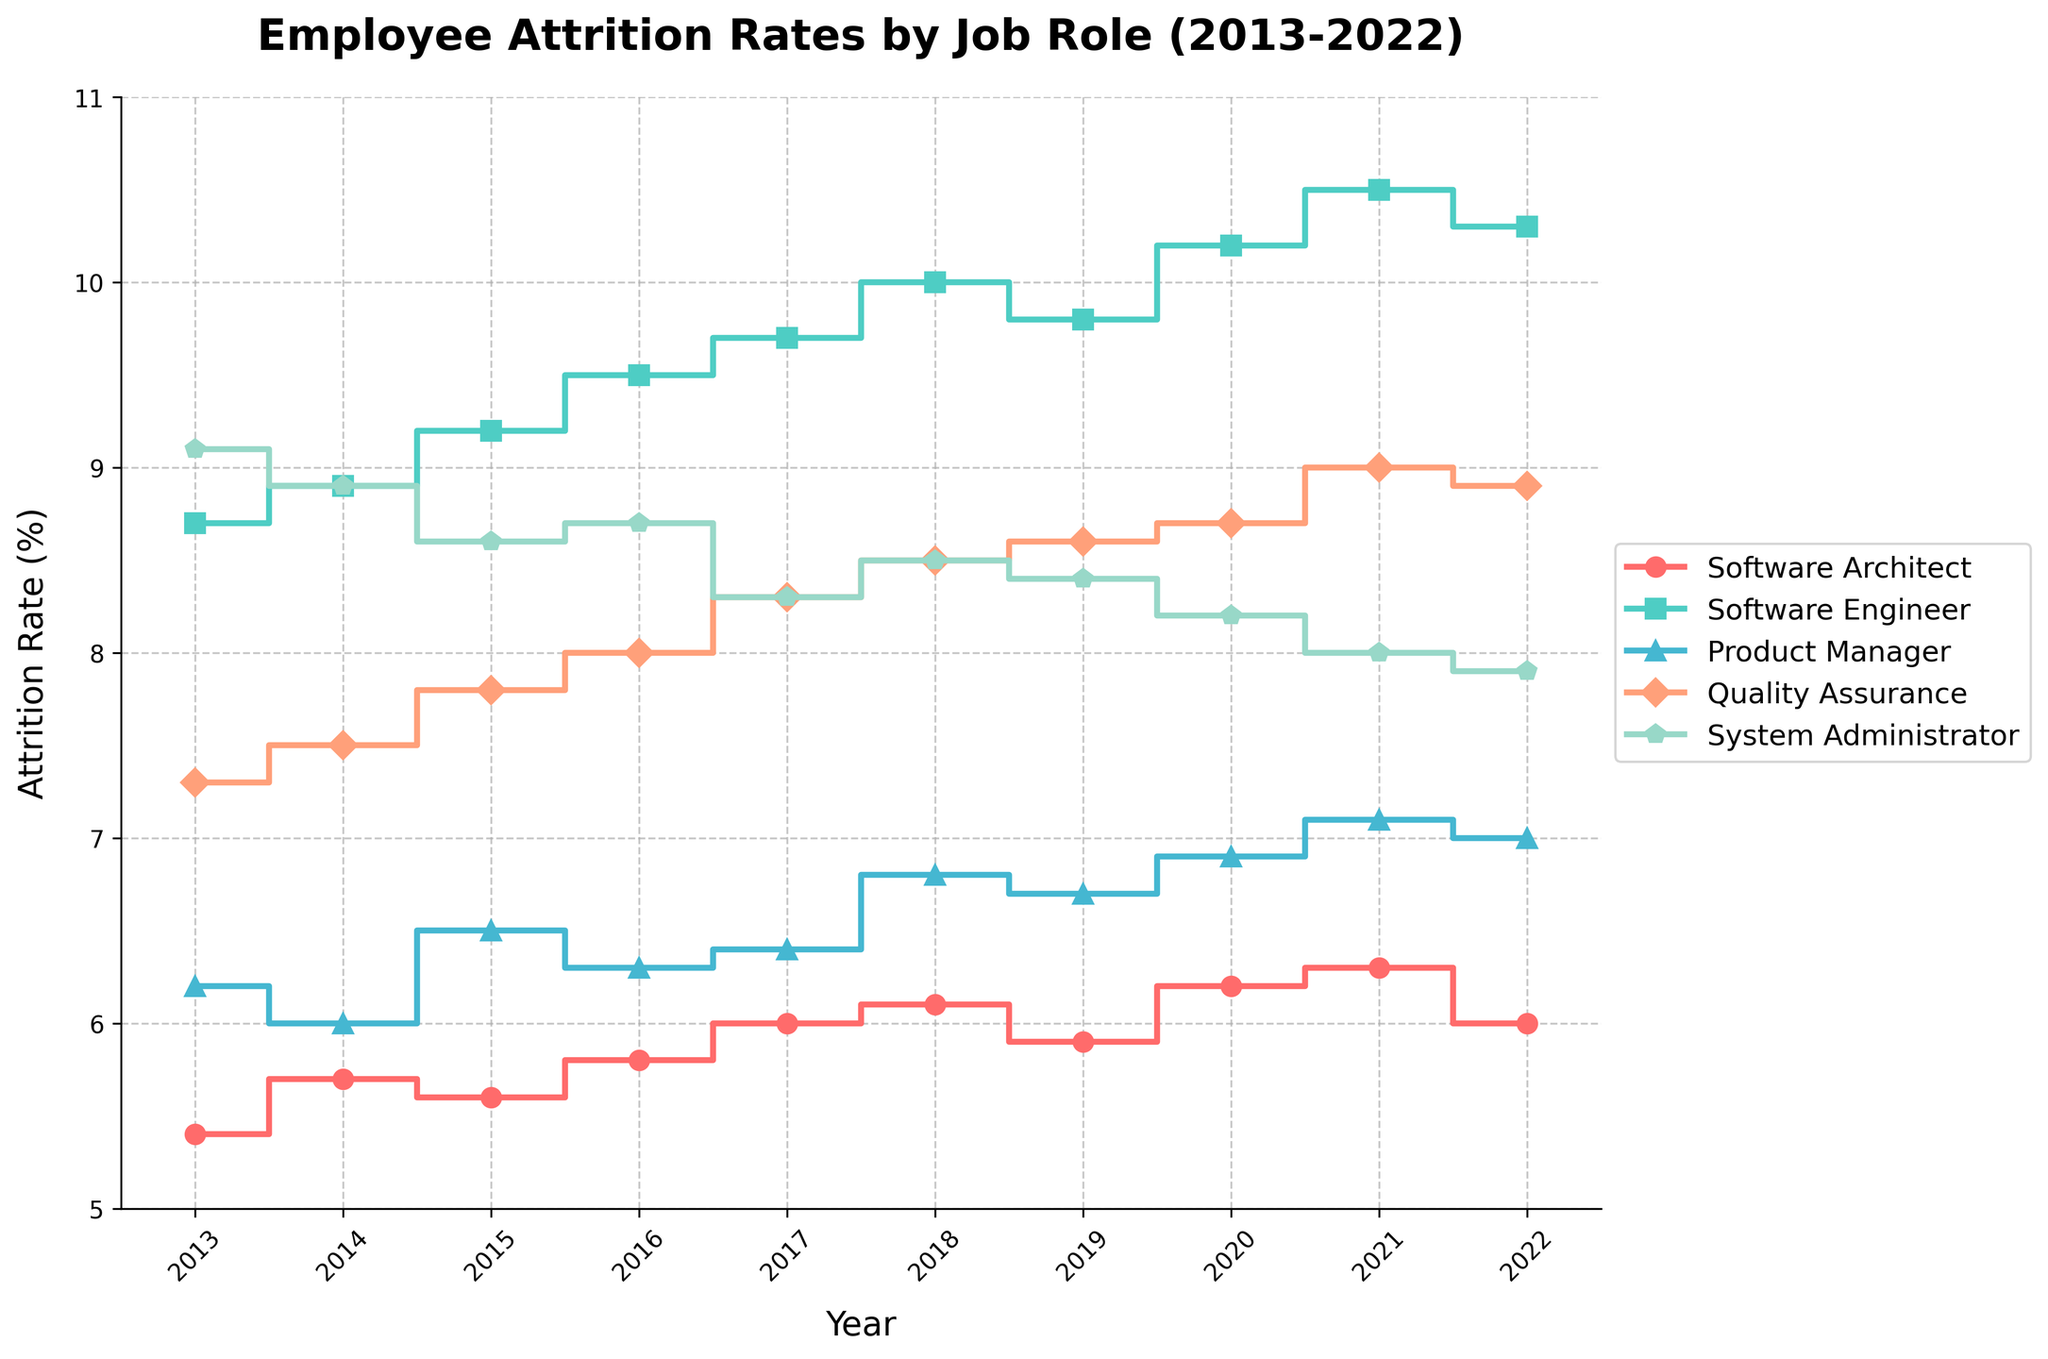Which job role had the lowest attrition rate in 2013? The data shows different job roles' attrition rates in 2013. By comparing these rates, we see that the Software Architect had the lowest attrition rate of 5.4%.
Answer: Software Architect What is the average attrition rate of Software Engineers from 2013 to 2022? To find the average, sum all the attrition rates for Software Engineers from 2013 to 2022 and divide by the number of years. The sum is 85.8 and dividing by 10 years gives us an average rate of 8.58%.
Answer: 8.58% Which job role shows the most significant increase in attrition rate from 2013 to 2022? By comparing the attrition rates from 2013 to 2022 for all job roles, Software Engineers had an increase from 8.7% to 10.3%, which is the largest increase of 1.6%.
Answer: Software Engineer What was the attrition rate for Quality Assurance in 2020? From the given plot, the attrition rate for Quality Assurance in 2020 is 8.7%.
Answer: 8.7% How did the attrition rate for Product Managers change from 2019 to 2020? The attrition rate for Product Managers increased from 6.7% in 2019 to 6.9% in 2020.
Answer: Increased by 0.2% Among all job roles in 2022, which one had the highest attrition rate? By comparing all the attrition rates of different roles in 2022, Software Engineers had the highest attrition rate of 10.3%.
Answer: Software Engineer By what percentage did the attrition rate for System Administrators decrease from 2020 to 2022? The attrition rate for System Administrators was 8.2% in 2020 and decreased to 7.9% in 2022. The percentage decrease is ((8.2 - 7.9) / 8.2) * 100, which is approximately 3.66%.
Answer: 3.66% What is the general trend in attrition rates for Software Architects from 2013 to 2022? Analyzing the data for Software Architects over the years, the trend shows a gradual increase from 5.4% in 2013 to 6.3% in 2021 followed by a slight decrease to 6.0% in 2022.
Answer: Gradual increase then slight decrease Which year experienced the highest overall average attrition rate across all job roles? Calculate the average attrition rate for each year by summing attrition rates of all roles and dividing by the number of roles. The highest average is 8.95% in 2021.
Answer: 2021 Compare the attrition rate trends for Software Engineers and Quality Assurance roles between 2015 and 2020. The attrition rate for Software Engineers increased consistently from 9.2% to 10.2%, whereas for Quality Assurance, it increased from 7.8% to 8.7% with slight fluctuations. Software Engineers had a steeper increase compared to Quality Assurance.
Answer: Software Engineers had a steeper increase 